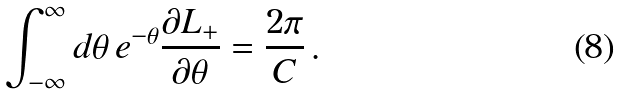<formula> <loc_0><loc_0><loc_500><loc_500>\int ^ { \infty } _ { - \infty } d \theta \, e ^ { - \theta } \frac { \partial L _ { + } } { \partial \theta } = \frac { 2 \pi } { C } \, .</formula> 